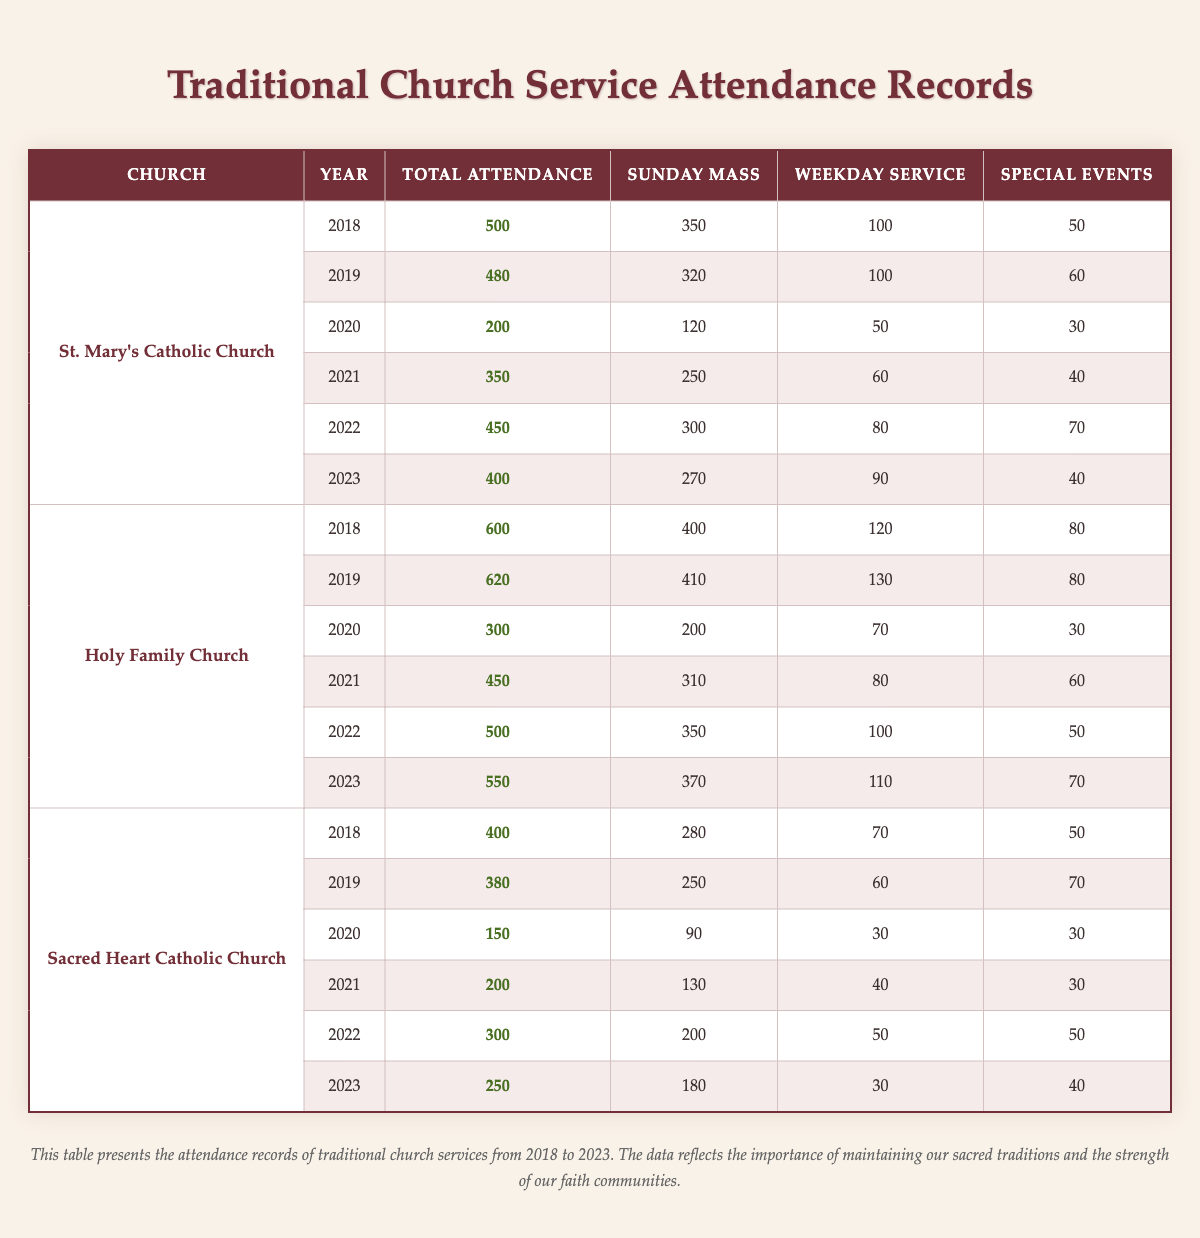What was the total attendance at St. Mary's Catholic Church in 2020? Referring to the table, for St. Mary's Catholic Church, the attendance listed for the year 2020 is 200.
Answer: 200 In which year did Holy Family Church have its highest Sunday Mass attendance? The table shows that Holy Family Church had the highest Sunday Mass attendance of 410 in 2019.
Answer: 2019 What is the average total attendance for Sacred Heart Catholic Church over the years? To find the average, sum the total attendance values (400 + 380 + 150 + 200 + 300 + 250 = 1680) and divide by the number of years (6). Thus, the average is 1680/6 = 280.
Answer: 280 Did the total attendance at Holy Family Church increase every year from 2018 to 2023? Looking at the attendance data, it shows that attendance decreased in 2020 compared to 2019, so the statement is false.
Answer: No What was the difference in total attendance between 2018 and 2022 for St. Mary's Catholic Church? The total attendance for St. Mary's in 2018 was 500, and in 2022 it was 450. The difference is 500 - 450 = 50.
Answer: 50 Which church had the lowest total attendance in 2020? The table shows Sacred Heart Catholic Church had the lowest total attendance of 150 in 2020 compared to other churches.
Answer: Sacred Heart Catholic Church What percentage of the total attendance at Holy Family Church in 2019 was from Sunday Mass? To determine this, divide the Sunday Mass attendance (410) by the total attendance (620) and multiply by 100. (410/620) * 100 = 66.45%.
Answer: 66.45% Identify the year where St. Mary's Catholic Church had more weekday services than Sunday Mass. In 2020, St. Mary's had 50 weekday services and only 120 Sunday Masses, therefore it did not have more weekday services. This holds true for all years in the table.
Answer: No such year exists For how many years did the attendance drop at Sacred Heart Catholic Church compared to the previous year? By checking the attendance each year: 2018 to 2019 (dropped), 2019 to 2020 (dropped), 2020 to 2021 (dropped), and 2021 to 2022 (increased), hence, the attendance dropped for 3 out of the 6 years.
Answer: 3 years 